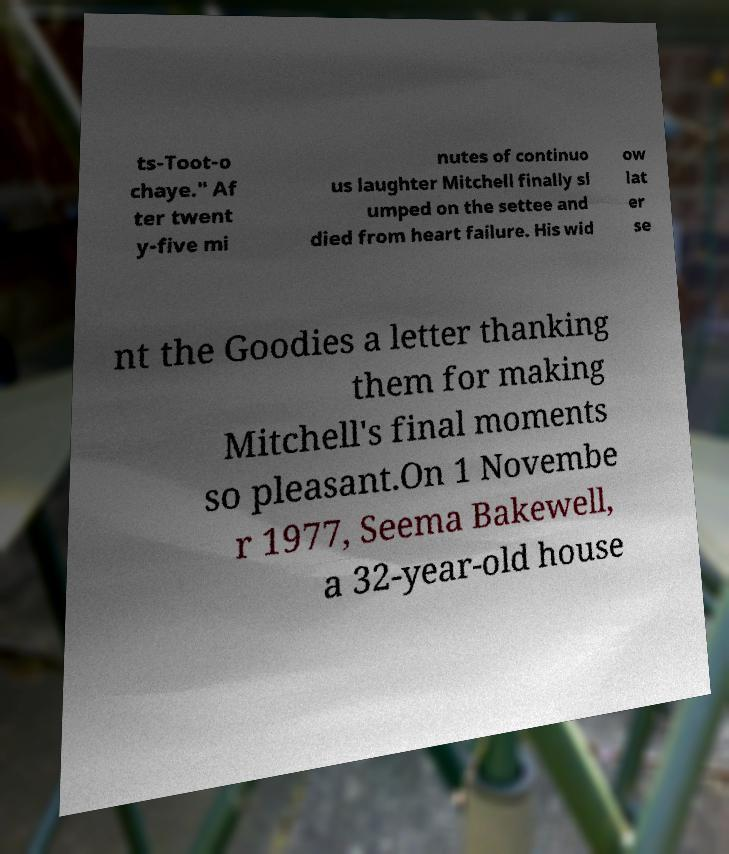Can you read and provide the text displayed in the image?This photo seems to have some interesting text. Can you extract and type it out for me? ts-Toot-o chaye." Af ter twent y-five mi nutes of continuo us laughter Mitchell finally sl umped on the settee and died from heart failure. His wid ow lat er se nt the Goodies a letter thanking them for making Mitchell's final moments so pleasant.On 1 Novembe r 1977, Seema Bakewell, a 32-year-old house 